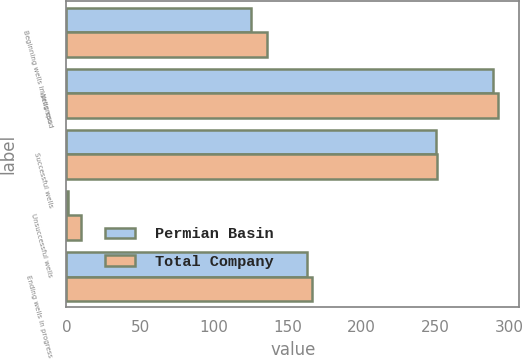<chart> <loc_0><loc_0><loc_500><loc_500><stacked_bar_chart><ecel><fcel>Beginning wells in progress<fcel>Wells spud<fcel>Successful wells<fcel>Unsuccessful wells<fcel>Ending wells in progress<nl><fcel>Permian Basin<fcel>125<fcel>289<fcel>250<fcel>1<fcel>163<nl><fcel>Total Company<fcel>136<fcel>292<fcel>251<fcel>10<fcel>166<nl></chart> 